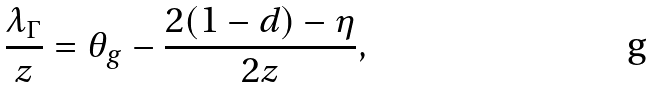<formula> <loc_0><loc_0><loc_500><loc_500>\frac { \lambda _ { \Gamma } } { z } = \theta _ { g } - \frac { 2 ( 1 - d ) - \eta } { 2 z } ,</formula> 